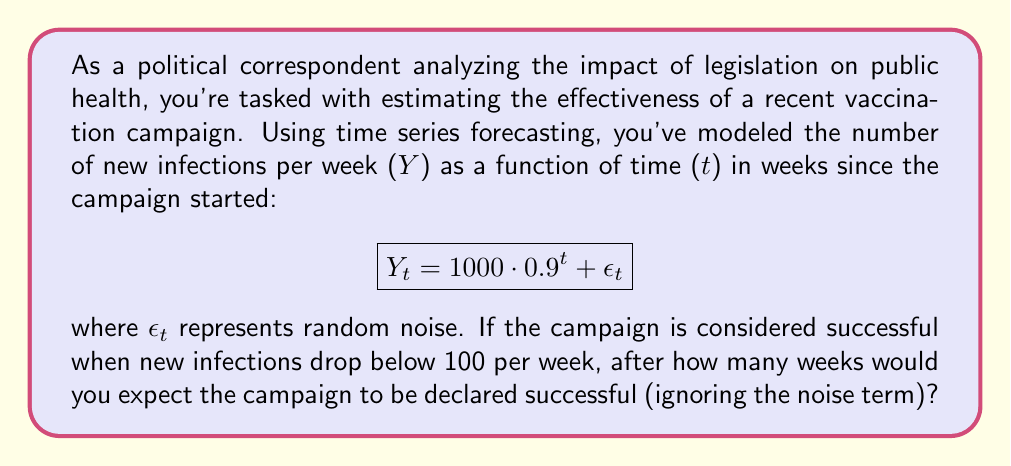Give your solution to this math problem. To solve this problem, we need to determine when the expected number of new infections falls below 100. We can ignore the noise term $\epsilon_t$ as specified in the question.

1. Set up the equation:
   $$100 = 1000 \cdot 0.9^t$$

2. Divide both sides by 1000:
   $$0.1 = 0.9^t$$

3. Take the natural logarithm of both sides:
   $$\ln(0.1) = t \cdot \ln(0.9)$$

4. Solve for t:
   $$t = \frac{\ln(0.1)}{\ln(0.9)}$$

5. Calculate the result:
   $$t = \frac{\ln(0.1)}{\ln(0.9)} \approx 21.85$$

6. Since we can only have whole weeks, we need to round up to the next integer:
   $$t = \lceil 21.85 \rceil = 22$$

Therefore, we would expect the campaign to be declared successful after 22 weeks.
Answer: 22 weeks 